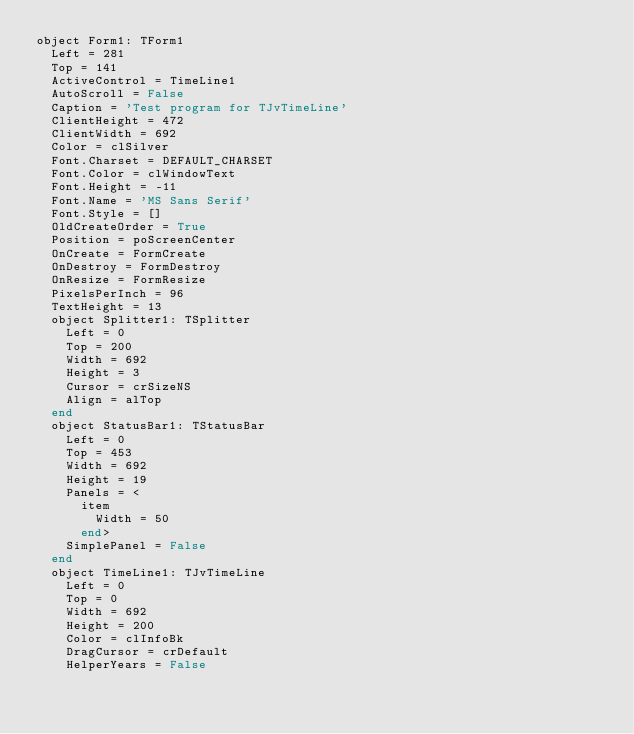<code> <loc_0><loc_0><loc_500><loc_500><_Pascal_>object Form1: TForm1
  Left = 281
  Top = 141
  ActiveControl = TimeLine1
  AutoScroll = False
  Caption = 'Test program for TJvTimeLine'
  ClientHeight = 472
  ClientWidth = 692
  Color = clSilver
  Font.Charset = DEFAULT_CHARSET
  Font.Color = clWindowText
  Font.Height = -11
  Font.Name = 'MS Sans Serif'
  Font.Style = []
  OldCreateOrder = True
  Position = poScreenCenter
  OnCreate = FormCreate
  OnDestroy = FormDestroy
  OnResize = FormResize
  PixelsPerInch = 96
  TextHeight = 13
  object Splitter1: TSplitter
    Left = 0
    Top = 200
    Width = 692
    Height = 3
    Cursor = crSizeNS
    Align = alTop
  end
  object StatusBar1: TStatusBar
    Left = 0
    Top = 453
    Width = 692
    Height = 19
    Panels = <
      item
        Width = 50
      end>
    SimplePanel = False
  end
  object TimeLine1: TJvTimeLine
    Left = 0
    Top = 0
    Width = 692
    Height = 200
    Color = clInfoBk
    DragCursor = crDefault
    HelperYears = False</code> 